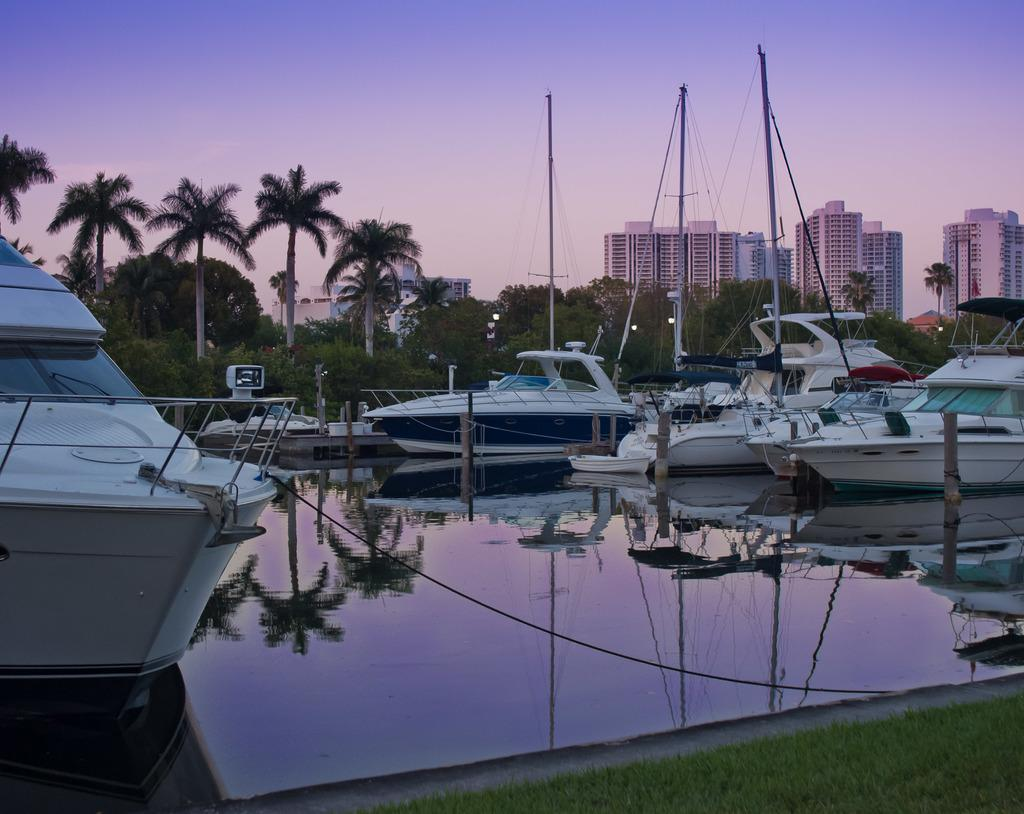What type of vehicles are in the image? There are boats in the image. Where are the boats located? The boats are on a canal. What can be seen in the background of the image? There are trees, buildings, and the sky visible in the background of the image. What flavor of straw can be seen in the image? There is no straw present in the image, so it is not possible to determine its flavor. 